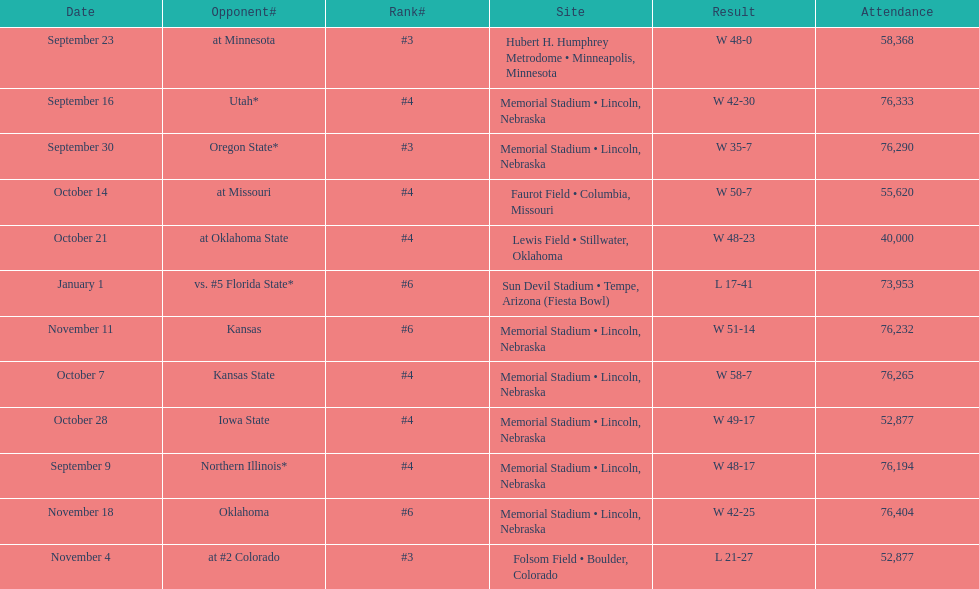On average, how often is "w" listed as the outcome? 10. 